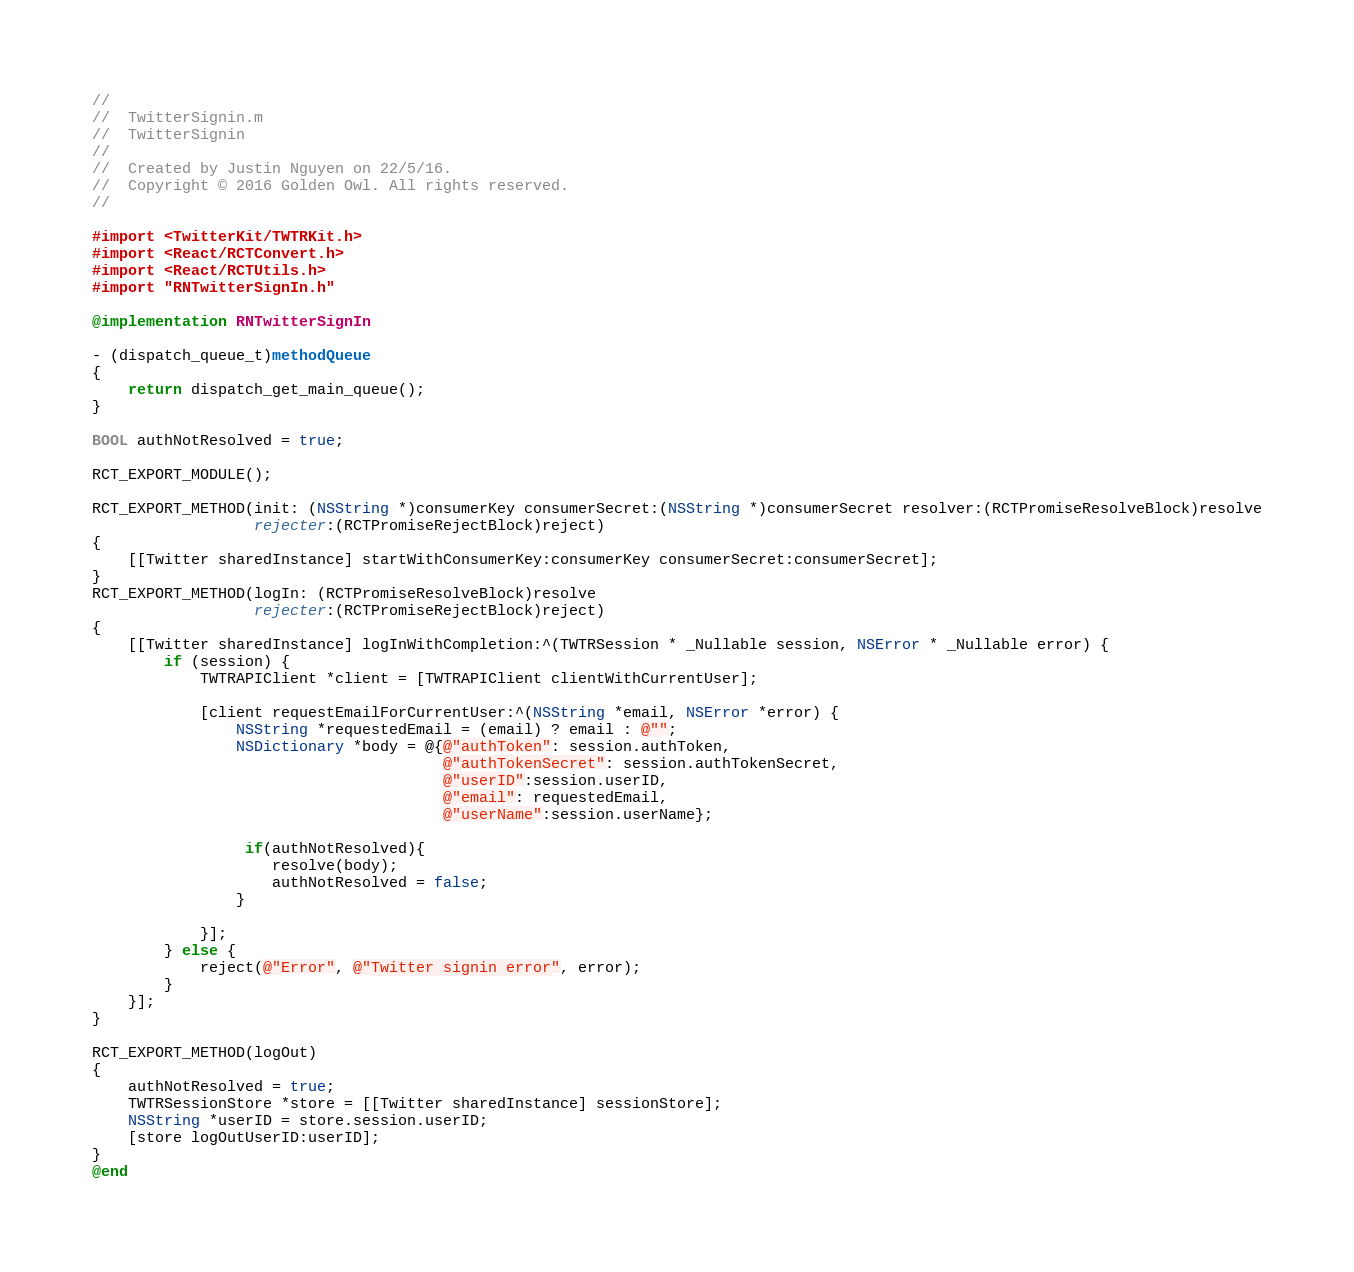Convert code to text. <code><loc_0><loc_0><loc_500><loc_500><_ObjectiveC_>//
//  TwitterSignin.m
//  TwitterSignin
//
//  Created by Justin Nguyen on 22/5/16.
//  Copyright © 2016 Golden Owl. All rights reserved.
//

#import <TwitterKit/TWTRKit.h>
#import <React/RCTConvert.h>
#import <React/RCTUtils.h>
#import "RNTwitterSignIn.h"

@implementation RNTwitterSignIn

- (dispatch_queue_t)methodQueue
{
    return dispatch_get_main_queue();
}

BOOL authNotResolved = true;

RCT_EXPORT_MODULE();

RCT_EXPORT_METHOD(init: (NSString *)consumerKey consumerSecret:(NSString *)consumerSecret resolver:(RCTPromiseResolveBlock)resolve
                  rejecter:(RCTPromiseRejectBlock)reject)
{
    [[Twitter sharedInstance] startWithConsumerKey:consumerKey consumerSecret:consumerSecret];
}
RCT_EXPORT_METHOD(logIn: (RCTPromiseResolveBlock)resolve
                  rejecter:(RCTPromiseRejectBlock)reject)
{
    [[Twitter sharedInstance] logInWithCompletion:^(TWTRSession * _Nullable session, NSError * _Nullable error) {
        if (session) {
            TWTRAPIClient *client = [TWTRAPIClient clientWithCurrentUser];

            [client requestEmailForCurrentUser:^(NSString *email, NSError *error) {
                NSString *requestedEmail = (email) ? email : @"";
                NSDictionary *body = @{@"authToken": session.authToken,
                                       @"authTokenSecret": session.authTokenSecret,
                                       @"userID":session.userID,
                                       @"email": requestedEmail,
                                       @"userName":session.userName};
                
                 if(authNotResolved){
                    resolve(body);
                    authNotResolved = false;
                }
                
            }];
        } else {
            reject(@"Error", @"Twitter signin error", error);
        }
    }];
}

RCT_EXPORT_METHOD(logOut)
{
    authNotResolved = true;
    TWTRSessionStore *store = [[Twitter sharedInstance] sessionStore];
    NSString *userID = store.session.userID;
    [store logOutUserID:userID];
}
@end
</code> 